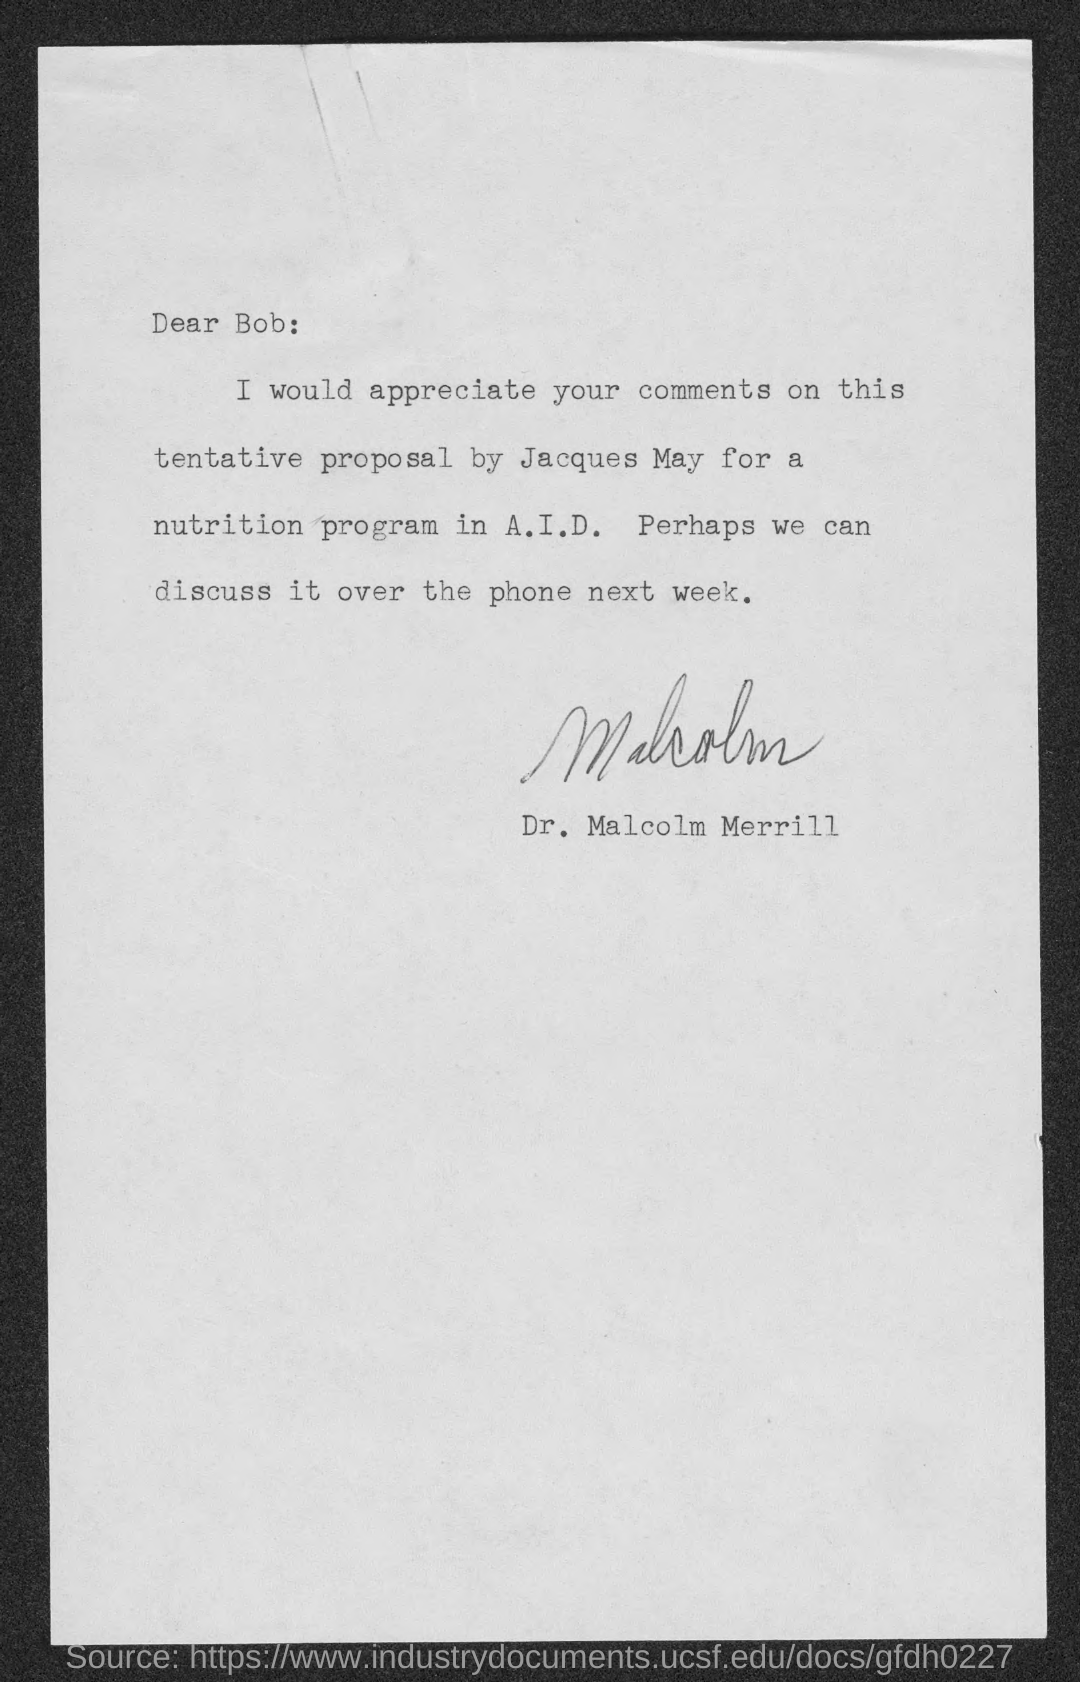Who is the sender of the letter?
Make the answer very short. Dr. Malcolm Merrill. Who made the proposal?
Offer a very short reply. Jacques. 